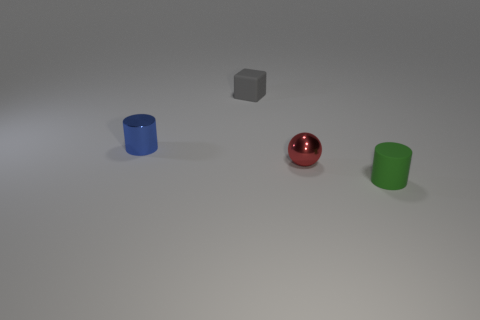What number of other things are the same shape as the red metallic thing?
Keep it short and to the point. 0. How many spheres are small blue objects or small green things?
Offer a very short reply. 0. How many rubber things are either tiny green cylinders or small cylinders?
Your answer should be compact. 1. There is a red object; is it the same size as the object left of the small matte cube?
Your answer should be compact. Yes. What shape is the object that is to the right of the tiny red shiny ball?
Offer a terse response. Cylinder. What color is the tiny thing behind the small cylinder that is behind the rubber cylinder?
Offer a terse response. Gray. The other tiny thing that is the same shape as the tiny blue object is what color?
Offer a terse response. Green. How many other small metallic cylinders are the same color as the small shiny cylinder?
Give a very brief answer. 0. What shape is the tiny object that is both left of the red shiny ball and in front of the small cube?
Your answer should be compact. Cylinder. What material is the small cylinder that is behind the cylinder to the right of the rubber thing that is behind the tiny metallic cylinder made of?
Your answer should be compact. Metal. 